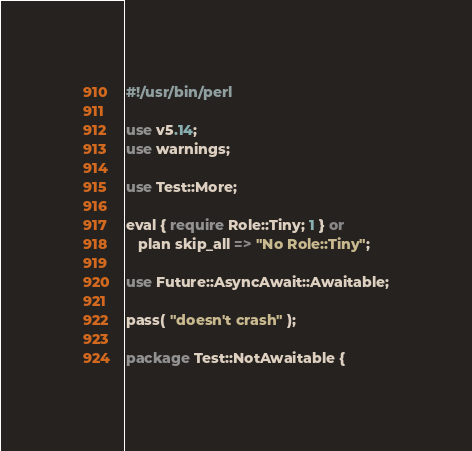Convert code to text. <code><loc_0><loc_0><loc_500><loc_500><_Perl_>#!/usr/bin/perl

use v5.14;
use warnings;

use Test::More;

eval { require Role::Tiny; 1 } or
   plan skip_all => "No Role::Tiny";

use Future::AsyncAwait::Awaitable;

pass( "doesn't crash" );

package Test::NotAwaitable {</code> 